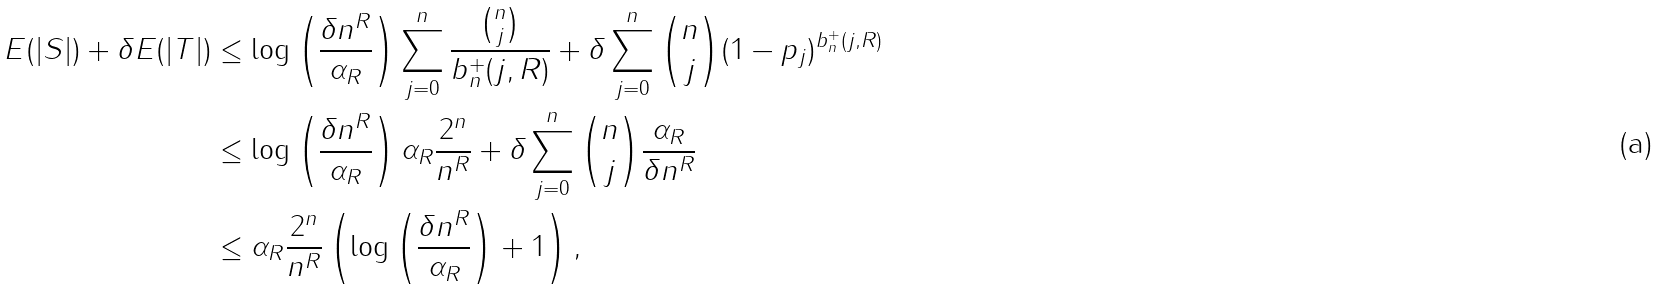<formula> <loc_0><loc_0><loc_500><loc_500>E ( | S | ) + \delta E ( | T | ) & \leq \log \left ( \frac { \delta n ^ { R } } { \alpha _ { R } } \right ) \sum _ { j = 0 } ^ { n } \frac { \binom { n } { j } } { b ^ { + } _ { n } ( j , R ) } + \delta \sum _ { j = 0 } ^ { n } \binom { n } { j } ( 1 - p _ { j } ) ^ { b ^ { + } _ { n } ( j , R ) } \quad \\ & \leq \log \left ( \frac { \delta n ^ { R } } { \alpha _ { R } } \right ) \alpha _ { R } \frac { 2 ^ { n } } { n ^ { R } } + \delta \sum _ { j = 0 } ^ { n } \binom { n } { j } \frac { \alpha _ { R } } { \delta n ^ { R } } \\ \quad & \leq \alpha _ { R } \frac { 2 ^ { n } } { n ^ { R } } \left ( \log \left ( \frac { \delta n ^ { R } } { \alpha _ { R } } \right ) + 1 \right ) ,</formula> 